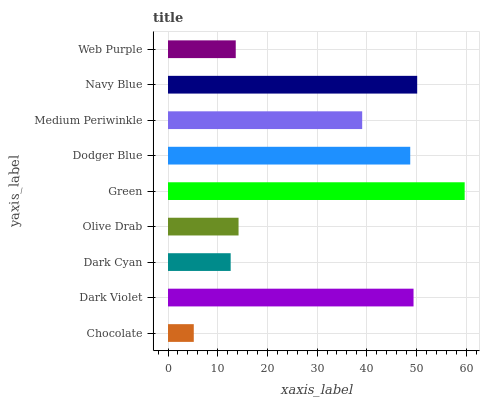Is Chocolate the minimum?
Answer yes or no. Yes. Is Green the maximum?
Answer yes or no. Yes. Is Dark Violet the minimum?
Answer yes or no. No. Is Dark Violet the maximum?
Answer yes or no. No. Is Dark Violet greater than Chocolate?
Answer yes or no. Yes. Is Chocolate less than Dark Violet?
Answer yes or no. Yes. Is Chocolate greater than Dark Violet?
Answer yes or no. No. Is Dark Violet less than Chocolate?
Answer yes or no. No. Is Medium Periwinkle the high median?
Answer yes or no. Yes. Is Medium Periwinkle the low median?
Answer yes or no. Yes. Is Navy Blue the high median?
Answer yes or no. No. Is Navy Blue the low median?
Answer yes or no. No. 